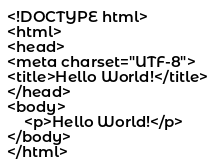Convert code to text. <code><loc_0><loc_0><loc_500><loc_500><_PHP_><!DOCTYPE html>
<html>
<head>
<meta charset="UTF-8">
<title>Hello World!</title>
</head>
<body>
    <p>Hello World!</p>
</body>
</html></code> 